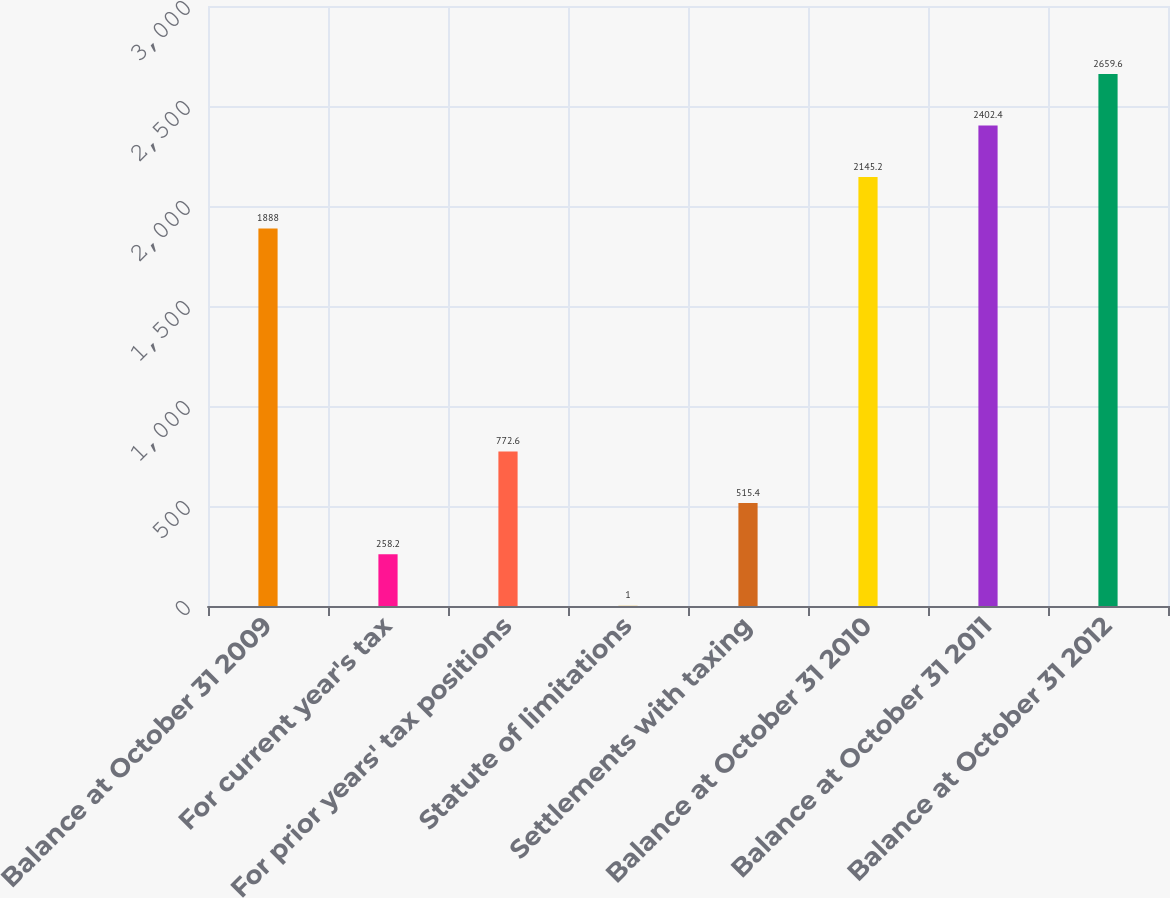Convert chart to OTSL. <chart><loc_0><loc_0><loc_500><loc_500><bar_chart><fcel>Balance at October 31 2009<fcel>For current year's tax<fcel>For prior years' tax positions<fcel>Statute of limitations<fcel>Settlements with taxing<fcel>Balance at October 31 2010<fcel>Balance at October 31 2011<fcel>Balance at October 31 2012<nl><fcel>1888<fcel>258.2<fcel>772.6<fcel>1<fcel>515.4<fcel>2145.2<fcel>2402.4<fcel>2659.6<nl></chart> 